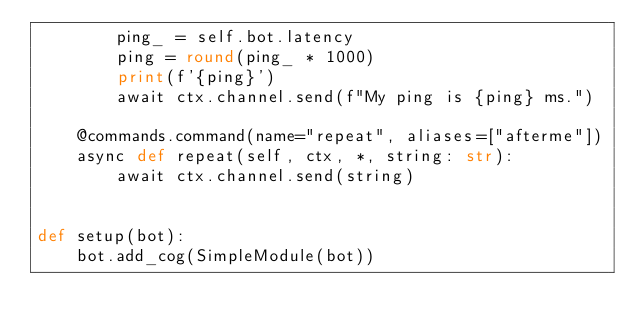Convert code to text. <code><loc_0><loc_0><loc_500><loc_500><_Python_>        ping_ = self.bot.latency
        ping = round(ping_ * 1000)
        print(f'{ping}')
        await ctx.channel.send(f"My ping is {ping} ms.")

    @commands.command(name="repeat", aliases=["afterme"])
    async def repeat(self, ctx, *, string: str):
        await ctx.channel.send(string)


def setup(bot):
    bot.add_cog(SimpleModule(bot))
</code> 